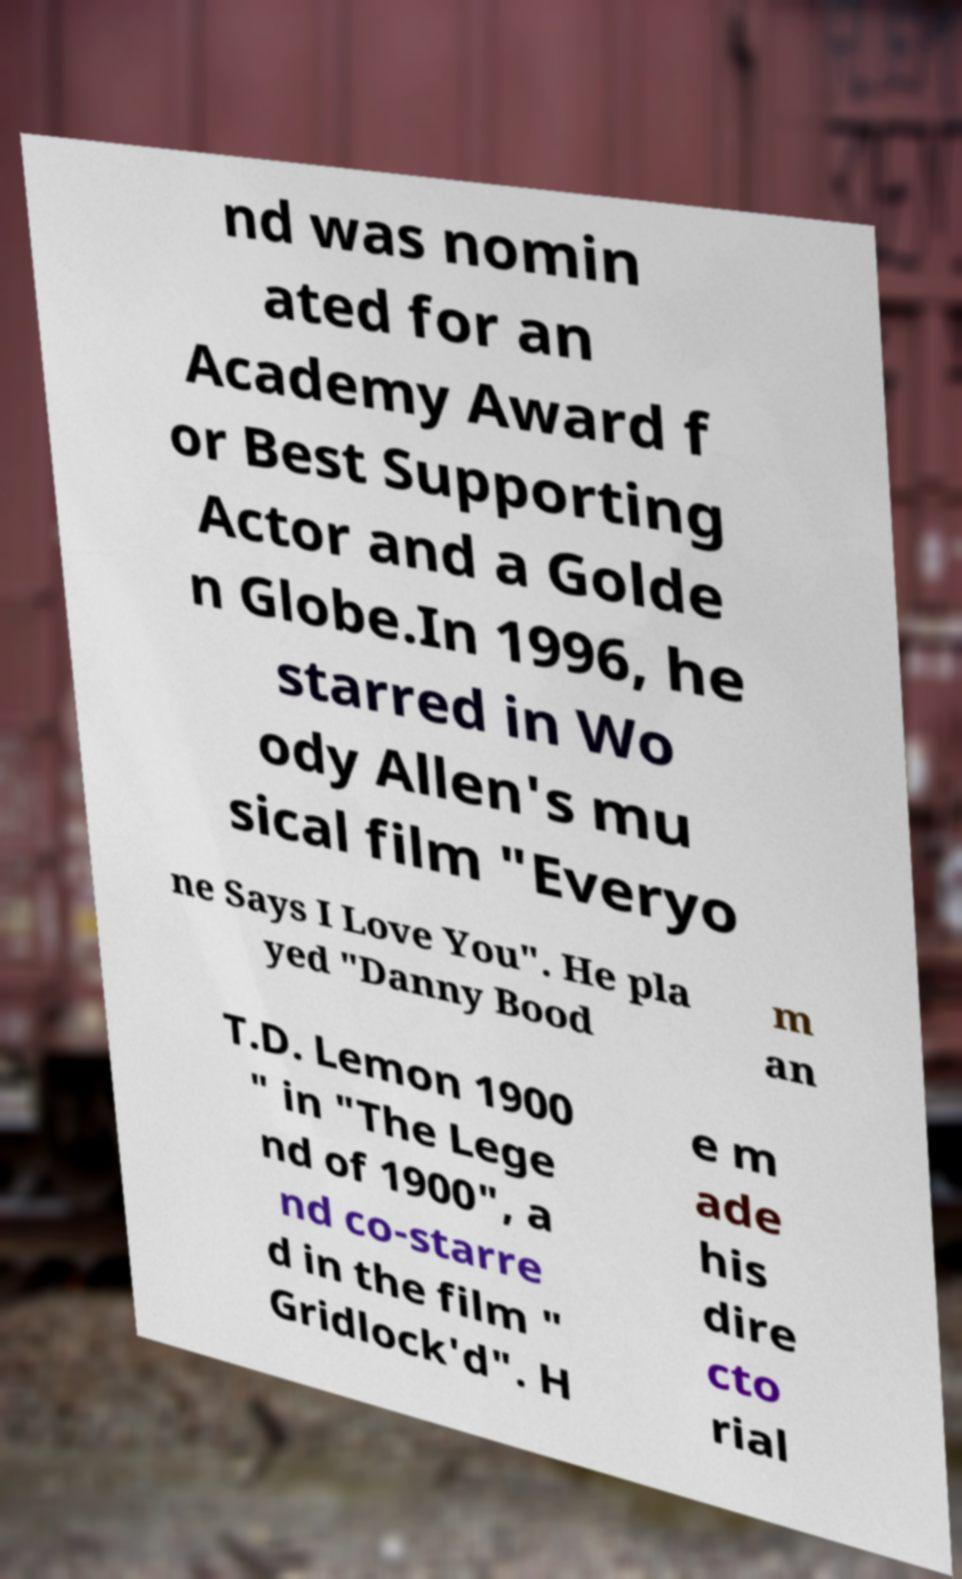Please read and relay the text visible in this image. What does it say? nd was nomin ated for an Academy Award f or Best Supporting Actor and a Golde n Globe.In 1996, he starred in Wo ody Allen's mu sical film "Everyo ne Says I Love You". He pla yed "Danny Bood m an T.D. Lemon 1900 " in "The Lege nd of 1900", a nd co-starre d in the film " Gridlock'd". H e m ade his dire cto rial 